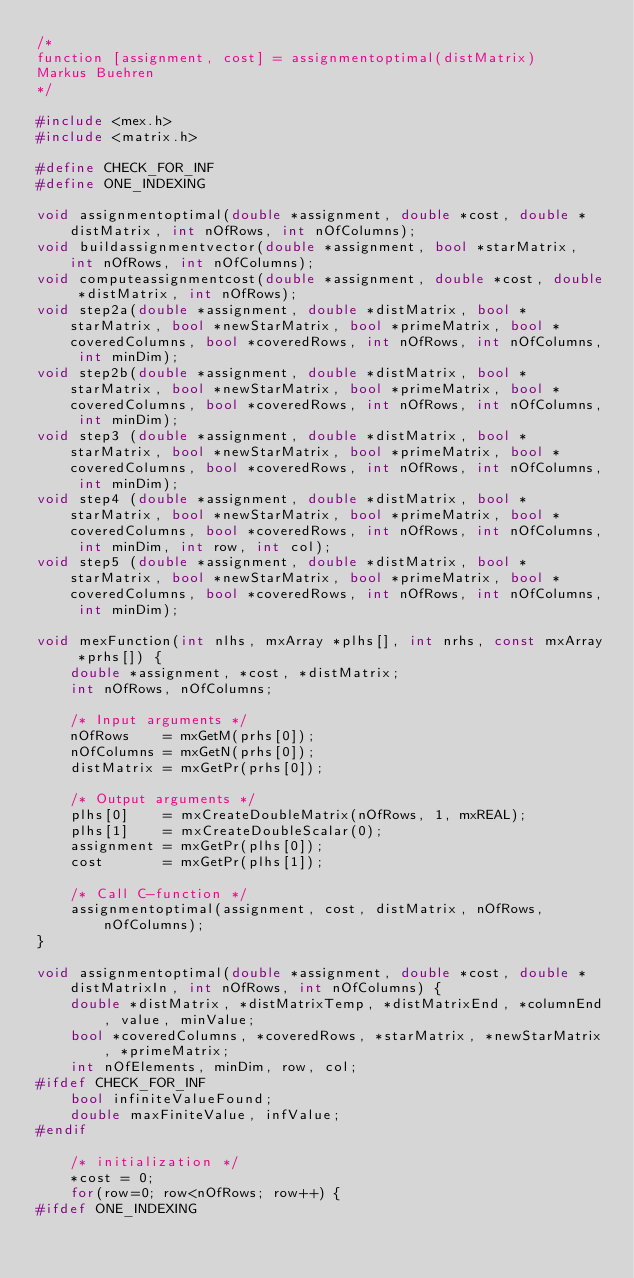<code> <loc_0><loc_0><loc_500><loc_500><_C++_>/*
function [assignment, cost] = assignmentoptimal(distMatrix)
Markus Buehren
*/

#include <mex.h>
#include <matrix.h>

#define CHECK_FOR_INF
#define ONE_INDEXING

void assignmentoptimal(double *assignment, double *cost, double *distMatrix, int nOfRows, int nOfColumns);
void buildassignmentvector(double *assignment, bool *starMatrix, int nOfRows, int nOfColumns);
void computeassignmentcost(double *assignment, double *cost, double *distMatrix, int nOfRows);
void step2a(double *assignment, double *distMatrix, bool *starMatrix, bool *newStarMatrix, bool *primeMatrix, bool *coveredColumns, bool *coveredRows, int nOfRows, int nOfColumns, int minDim);
void step2b(double *assignment, double *distMatrix, bool *starMatrix, bool *newStarMatrix, bool *primeMatrix, bool *coveredColumns, bool *coveredRows, int nOfRows, int nOfColumns, int minDim);
void step3 (double *assignment, double *distMatrix, bool *starMatrix, bool *newStarMatrix, bool *primeMatrix, bool *coveredColumns, bool *coveredRows, int nOfRows, int nOfColumns, int minDim);
void step4 (double *assignment, double *distMatrix, bool *starMatrix, bool *newStarMatrix, bool *primeMatrix, bool *coveredColumns, bool *coveredRows, int nOfRows, int nOfColumns, int minDim, int row, int col);
void step5 (double *assignment, double *distMatrix, bool *starMatrix, bool *newStarMatrix, bool *primeMatrix, bool *coveredColumns, bool *coveredRows, int nOfRows, int nOfColumns, int minDim);

void mexFunction(int nlhs, mxArray *plhs[], int nrhs, const mxArray *prhs[]) {
    double *assignment, *cost, *distMatrix;
    int nOfRows, nOfColumns;

    /* Input arguments */
    nOfRows    = mxGetM(prhs[0]);
    nOfColumns = mxGetN(prhs[0]);
    distMatrix = mxGetPr(prhs[0]);
	
    /* Output arguments */
    plhs[0]    = mxCreateDoubleMatrix(nOfRows, 1, mxREAL);
    plhs[1]    = mxCreateDoubleScalar(0);
    assignment = mxGetPr(plhs[0]);
    cost       = mxGetPr(plhs[1]);
	
    /* Call C-function */
    assignmentoptimal(assignment, cost, distMatrix, nOfRows, nOfColumns);
}

void assignmentoptimal(double *assignment, double *cost, double *distMatrixIn, int nOfRows, int nOfColumns) {
    double *distMatrix, *distMatrixTemp, *distMatrixEnd, *columnEnd, value, minValue;
    bool *coveredColumns, *coveredRows, *starMatrix, *newStarMatrix, *primeMatrix;
    int nOfElements, minDim, row, col;
#ifdef CHECK_FOR_INF
    bool infiniteValueFound;
    double maxFiniteValue, infValue;
#endif
	
    /* initialization */
    *cost = 0;
    for(row=0; row<nOfRows; row++) {
#ifdef ONE_INDEXING</code> 